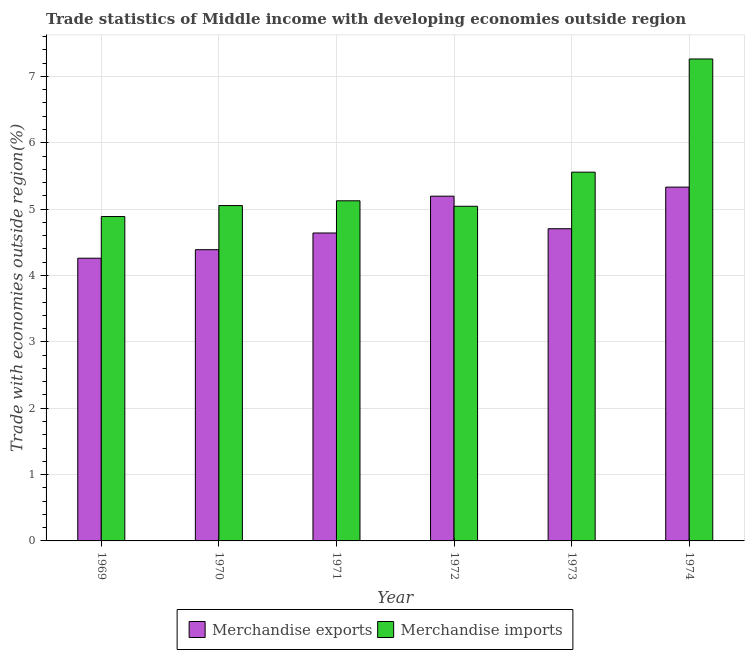How many different coloured bars are there?
Provide a succinct answer. 2. Are the number of bars on each tick of the X-axis equal?
Your answer should be very brief. Yes. How many bars are there on the 1st tick from the left?
Your response must be concise. 2. What is the merchandise exports in 1969?
Ensure brevity in your answer.  4.26. Across all years, what is the maximum merchandise imports?
Your response must be concise. 7.26. Across all years, what is the minimum merchandise imports?
Keep it short and to the point. 4.89. In which year was the merchandise exports maximum?
Give a very brief answer. 1974. In which year was the merchandise exports minimum?
Make the answer very short. 1969. What is the total merchandise exports in the graph?
Your answer should be compact. 28.52. What is the difference between the merchandise imports in 1972 and that in 1973?
Provide a succinct answer. -0.51. What is the difference between the merchandise imports in 1971 and the merchandise exports in 1973?
Offer a very short reply. -0.43. What is the average merchandise imports per year?
Ensure brevity in your answer.  5.49. In the year 1970, what is the difference between the merchandise exports and merchandise imports?
Make the answer very short. 0. In how many years, is the merchandise imports greater than 2.2 %?
Ensure brevity in your answer.  6. What is the ratio of the merchandise exports in 1970 to that in 1971?
Keep it short and to the point. 0.95. Is the difference between the merchandise imports in 1969 and 1973 greater than the difference between the merchandise exports in 1969 and 1973?
Your answer should be very brief. No. What is the difference between the highest and the second highest merchandise imports?
Provide a short and direct response. 1.71. What is the difference between the highest and the lowest merchandise imports?
Keep it short and to the point. 2.37. Is the sum of the merchandise exports in 1970 and 1973 greater than the maximum merchandise imports across all years?
Offer a terse response. Yes. What does the 2nd bar from the left in 1972 represents?
Your answer should be compact. Merchandise imports. How many years are there in the graph?
Keep it short and to the point. 6. Where does the legend appear in the graph?
Offer a very short reply. Bottom center. How many legend labels are there?
Ensure brevity in your answer.  2. How are the legend labels stacked?
Provide a short and direct response. Horizontal. What is the title of the graph?
Keep it short and to the point. Trade statistics of Middle income with developing economies outside region. What is the label or title of the Y-axis?
Keep it short and to the point. Trade with economies outside region(%). What is the Trade with economies outside region(%) in Merchandise exports in 1969?
Your response must be concise. 4.26. What is the Trade with economies outside region(%) in Merchandise imports in 1969?
Give a very brief answer. 4.89. What is the Trade with economies outside region(%) in Merchandise exports in 1970?
Make the answer very short. 4.39. What is the Trade with economies outside region(%) of Merchandise imports in 1970?
Offer a very short reply. 5.05. What is the Trade with economies outside region(%) in Merchandise exports in 1971?
Ensure brevity in your answer.  4.64. What is the Trade with economies outside region(%) of Merchandise imports in 1971?
Your response must be concise. 5.13. What is the Trade with economies outside region(%) in Merchandise exports in 1972?
Your answer should be compact. 5.2. What is the Trade with economies outside region(%) of Merchandise imports in 1972?
Keep it short and to the point. 5.04. What is the Trade with economies outside region(%) in Merchandise exports in 1973?
Provide a short and direct response. 4.7. What is the Trade with economies outside region(%) of Merchandise imports in 1973?
Your response must be concise. 5.56. What is the Trade with economies outside region(%) in Merchandise exports in 1974?
Make the answer very short. 5.33. What is the Trade with economies outside region(%) in Merchandise imports in 1974?
Your answer should be compact. 7.26. Across all years, what is the maximum Trade with economies outside region(%) in Merchandise exports?
Keep it short and to the point. 5.33. Across all years, what is the maximum Trade with economies outside region(%) of Merchandise imports?
Provide a short and direct response. 7.26. Across all years, what is the minimum Trade with economies outside region(%) of Merchandise exports?
Ensure brevity in your answer.  4.26. Across all years, what is the minimum Trade with economies outside region(%) in Merchandise imports?
Offer a very short reply. 4.89. What is the total Trade with economies outside region(%) of Merchandise exports in the graph?
Give a very brief answer. 28.52. What is the total Trade with economies outside region(%) of Merchandise imports in the graph?
Your response must be concise. 32.93. What is the difference between the Trade with economies outside region(%) of Merchandise exports in 1969 and that in 1970?
Offer a terse response. -0.13. What is the difference between the Trade with economies outside region(%) in Merchandise imports in 1969 and that in 1970?
Your answer should be compact. -0.17. What is the difference between the Trade with economies outside region(%) in Merchandise exports in 1969 and that in 1971?
Make the answer very short. -0.38. What is the difference between the Trade with economies outside region(%) of Merchandise imports in 1969 and that in 1971?
Your response must be concise. -0.24. What is the difference between the Trade with economies outside region(%) of Merchandise exports in 1969 and that in 1972?
Offer a very short reply. -0.93. What is the difference between the Trade with economies outside region(%) in Merchandise imports in 1969 and that in 1972?
Ensure brevity in your answer.  -0.15. What is the difference between the Trade with economies outside region(%) of Merchandise exports in 1969 and that in 1973?
Give a very brief answer. -0.44. What is the difference between the Trade with economies outside region(%) of Merchandise imports in 1969 and that in 1973?
Make the answer very short. -0.67. What is the difference between the Trade with economies outside region(%) in Merchandise exports in 1969 and that in 1974?
Make the answer very short. -1.07. What is the difference between the Trade with economies outside region(%) of Merchandise imports in 1969 and that in 1974?
Your response must be concise. -2.37. What is the difference between the Trade with economies outside region(%) in Merchandise exports in 1970 and that in 1971?
Offer a terse response. -0.25. What is the difference between the Trade with economies outside region(%) in Merchandise imports in 1970 and that in 1971?
Make the answer very short. -0.07. What is the difference between the Trade with economies outside region(%) of Merchandise exports in 1970 and that in 1972?
Offer a very short reply. -0.81. What is the difference between the Trade with economies outside region(%) of Merchandise imports in 1970 and that in 1972?
Your response must be concise. 0.01. What is the difference between the Trade with economies outside region(%) of Merchandise exports in 1970 and that in 1973?
Your answer should be very brief. -0.32. What is the difference between the Trade with economies outside region(%) of Merchandise imports in 1970 and that in 1973?
Your answer should be compact. -0.5. What is the difference between the Trade with economies outside region(%) in Merchandise exports in 1970 and that in 1974?
Make the answer very short. -0.94. What is the difference between the Trade with economies outside region(%) of Merchandise imports in 1970 and that in 1974?
Your answer should be compact. -2.21. What is the difference between the Trade with economies outside region(%) in Merchandise exports in 1971 and that in 1972?
Your answer should be very brief. -0.55. What is the difference between the Trade with economies outside region(%) of Merchandise imports in 1971 and that in 1972?
Your answer should be compact. 0.08. What is the difference between the Trade with economies outside region(%) in Merchandise exports in 1971 and that in 1973?
Your answer should be compact. -0.06. What is the difference between the Trade with economies outside region(%) of Merchandise imports in 1971 and that in 1973?
Your answer should be very brief. -0.43. What is the difference between the Trade with economies outside region(%) in Merchandise exports in 1971 and that in 1974?
Ensure brevity in your answer.  -0.69. What is the difference between the Trade with economies outside region(%) of Merchandise imports in 1971 and that in 1974?
Provide a succinct answer. -2.14. What is the difference between the Trade with economies outside region(%) of Merchandise exports in 1972 and that in 1973?
Your answer should be very brief. 0.49. What is the difference between the Trade with economies outside region(%) of Merchandise imports in 1972 and that in 1973?
Offer a very short reply. -0.51. What is the difference between the Trade with economies outside region(%) of Merchandise exports in 1972 and that in 1974?
Offer a terse response. -0.14. What is the difference between the Trade with economies outside region(%) of Merchandise imports in 1972 and that in 1974?
Offer a very short reply. -2.22. What is the difference between the Trade with economies outside region(%) of Merchandise exports in 1973 and that in 1974?
Your answer should be very brief. -0.63. What is the difference between the Trade with economies outside region(%) in Merchandise imports in 1973 and that in 1974?
Ensure brevity in your answer.  -1.71. What is the difference between the Trade with economies outside region(%) of Merchandise exports in 1969 and the Trade with economies outside region(%) of Merchandise imports in 1970?
Your response must be concise. -0.79. What is the difference between the Trade with economies outside region(%) in Merchandise exports in 1969 and the Trade with economies outside region(%) in Merchandise imports in 1971?
Your response must be concise. -0.87. What is the difference between the Trade with economies outside region(%) in Merchandise exports in 1969 and the Trade with economies outside region(%) in Merchandise imports in 1972?
Make the answer very short. -0.78. What is the difference between the Trade with economies outside region(%) of Merchandise exports in 1969 and the Trade with economies outside region(%) of Merchandise imports in 1973?
Your answer should be compact. -1.3. What is the difference between the Trade with economies outside region(%) of Merchandise exports in 1969 and the Trade with economies outside region(%) of Merchandise imports in 1974?
Keep it short and to the point. -3. What is the difference between the Trade with economies outside region(%) in Merchandise exports in 1970 and the Trade with economies outside region(%) in Merchandise imports in 1971?
Your answer should be very brief. -0.74. What is the difference between the Trade with economies outside region(%) in Merchandise exports in 1970 and the Trade with economies outside region(%) in Merchandise imports in 1972?
Your response must be concise. -0.65. What is the difference between the Trade with economies outside region(%) of Merchandise exports in 1970 and the Trade with economies outside region(%) of Merchandise imports in 1973?
Provide a short and direct response. -1.17. What is the difference between the Trade with economies outside region(%) of Merchandise exports in 1970 and the Trade with economies outside region(%) of Merchandise imports in 1974?
Provide a succinct answer. -2.87. What is the difference between the Trade with economies outside region(%) of Merchandise exports in 1971 and the Trade with economies outside region(%) of Merchandise imports in 1972?
Offer a very short reply. -0.4. What is the difference between the Trade with economies outside region(%) in Merchandise exports in 1971 and the Trade with economies outside region(%) in Merchandise imports in 1973?
Provide a succinct answer. -0.92. What is the difference between the Trade with economies outside region(%) in Merchandise exports in 1971 and the Trade with economies outside region(%) in Merchandise imports in 1974?
Your answer should be very brief. -2.62. What is the difference between the Trade with economies outside region(%) in Merchandise exports in 1972 and the Trade with economies outside region(%) in Merchandise imports in 1973?
Make the answer very short. -0.36. What is the difference between the Trade with economies outside region(%) in Merchandise exports in 1972 and the Trade with economies outside region(%) in Merchandise imports in 1974?
Ensure brevity in your answer.  -2.07. What is the difference between the Trade with economies outside region(%) of Merchandise exports in 1973 and the Trade with economies outside region(%) of Merchandise imports in 1974?
Provide a short and direct response. -2.56. What is the average Trade with economies outside region(%) in Merchandise exports per year?
Offer a terse response. 4.75. What is the average Trade with economies outside region(%) in Merchandise imports per year?
Give a very brief answer. 5.49. In the year 1969, what is the difference between the Trade with economies outside region(%) of Merchandise exports and Trade with economies outside region(%) of Merchandise imports?
Provide a short and direct response. -0.63. In the year 1970, what is the difference between the Trade with economies outside region(%) of Merchandise exports and Trade with economies outside region(%) of Merchandise imports?
Make the answer very short. -0.67. In the year 1971, what is the difference between the Trade with economies outside region(%) in Merchandise exports and Trade with economies outside region(%) in Merchandise imports?
Your answer should be compact. -0.49. In the year 1972, what is the difference between the Trade with economies outside region(%) of Merchandise exports and Trade with economies outside region(%) of Merchandise imports?
Give a very brief answer. 0.15. In the year 1973, what is the difference between the Trade with economies outside region(%) in Merchandise exports and Trade with economies outside region(%) in Merchandise imports?
Offer a very short reply. -0.85. In the year 1974, what is the difference between the Trade with economies outside region(%) in Merchandise exports and Trade with economies outside region(%) in Merchandise imports?
Your answer should be very brief. -1.93. What is the ratio of the Trade with economies outside region(%) of Merchandise exports in 1969 to that in 1970?
Provide a short and direct response. 0.97. What is the ratio of the Trade with economies outside region(%) of Merchandise imports in 1969 to that in 1970?
Make the answer very short. 0.97. What is the ratio of the Trade with economies outside region(%) in Merchandise exports in 1969 to that in 1971?
Ensure brevity in your answer.  0.92. What is the ratio of the Trade with economies outside region(%) of Merchandise imports in 1969 to that in 1971?
Provide a short and direct response. 0.95. What is the ratio of the Trade with economies outside region(%) in Merchandise exports in 1969 to that in 1972?
Keep it short and to the point. 0.82. What is the ratio of the Trade with economies outside region(%) of Merchandise imports in 1969 to that in 1972?
Your answer should be compact. 0.97. What is the ratio of the Trade with economies outside region(%) in Merchandise exports in 1969 to that in 1973?
Your answer should be compact. 0.91. What is the ratio of the Trade with economies outside region(%) in Merchandise imports in 1969 to that in 1973?
Provide a succinct answer. 0.88. What is the ratio of the Trade with economies outside region(%) in Merchandise exports in 1969 to that in 1974?
Offer a terse response. 0.8. What is the ratio of the Trade with economies outside region(%) of Merchandise imports in 1969 to that in 1974?
Your answer should be compact. 0.67. What is the ratio of the Trade with economies outside region(%) in Merchandise exports in 1970 to that in 1971?
Provide a succinct answer. 0.95. What is the ratio of the Trade with economies outside region(%) in Merchandise exports in 1970 to that in 1972?
Your response must be concise. 0.84. What is the ratio of the Trade with economies outside region(%) of Merchandise imports in 1970 to that in 1972?
Ensure brevity in your answer.  1. What is the ratio of the Trade with economies outside region(%) of Merchandise exports in 1970 to that in 1973?
Keep it short and to the point. 0.93. What is the ratio of the Trade with economies outside region(%) of Merchandise imports in 1970 to that in 1973?
Provide a short and direct response. 0.91. What is the ratio of the Trade with economies outside region(%) in Merchandise exports in 1970 to that in 1974?
Give a very brief answer. 0.82. What is the ratio of the Trade with economies outside region(%) of Merchandise imports in 1970 to that in 1974?
Provide a succinct answer. 0.7. What is the ratio of the Trade with economies outside region(%) of Merchandise exports in 1971 to that in 1972?
Your answer should be very brief. 0.89. What is the ratio of the Trade with economies outside region(%) in Merchandise imports in 1971 to that in 1972?
Your answer should be compact. 1.02. What is the ratio of the Trade with economies outside region(%) of Merchandise exports in 1971 to that in 1973?
Provide a succinct answer. 0.99. What is the ratio of the Trade with economies outside region(%) of Merchandise imports in 1971 to that in 1973?
Your answer should be very brief. 0.92. What is the ratio of the Trade with economies outside region(%) of Merchandise exports in 1971 to that in 1974?
Make the answer very short. 0.87. What is the ratio of the Trade with economies outside region(%) of Merchandise imports in 1971 to that in 1974?
Offer a terse response. 0.71. What is the ratio of the Trade with economies outside region(%) in Merchandise exports in 1972 to that in 1973?
Your answer should be compact. 1.1. What is the ratio of the Trade with economies outside region(%) of Merchandise imports in 1972 to that in 1973?
Offer a very short reply. 0.91. What is the ratio of the Trade with economies outside region(%) of Merchandise exports in 1972 to that in 1974?
Offer a terse response. 0.97. What is the ratio of the Trade with economies outside region(%) of Merchandise imports in 1972 to that in 1974?
Provide a succinct answer. 0.69. What is the ratio of the Trade with economies outside region(%) of Merchandise exports in 1973 to that in 1974?
Provide a succinct answer. 0.88. What is the ratio of the Trade with economies outside region(%) in Merchandise imports in 1973 to that in 1974?
Provide a short and direct response. 0.77. What is the difference between the highest and the second highest Trade with economies outside region(%) in Merchandise exports?
Provide a succinct answer. 0.14. What is the difference between the highest and the second highest Trade with economies outside region(%) of Merchandise imports?
Offer a terse response. 1.71. What is the difference between the highest and the lowest Trade with economies outside region(%) in Merchandise exports?
Keep it short and to the point. 1.07. What is the difference between the highest and the lowest Trade with economies outside region(%) in Merchandise imports?
Make the answer very short. 2.37. 